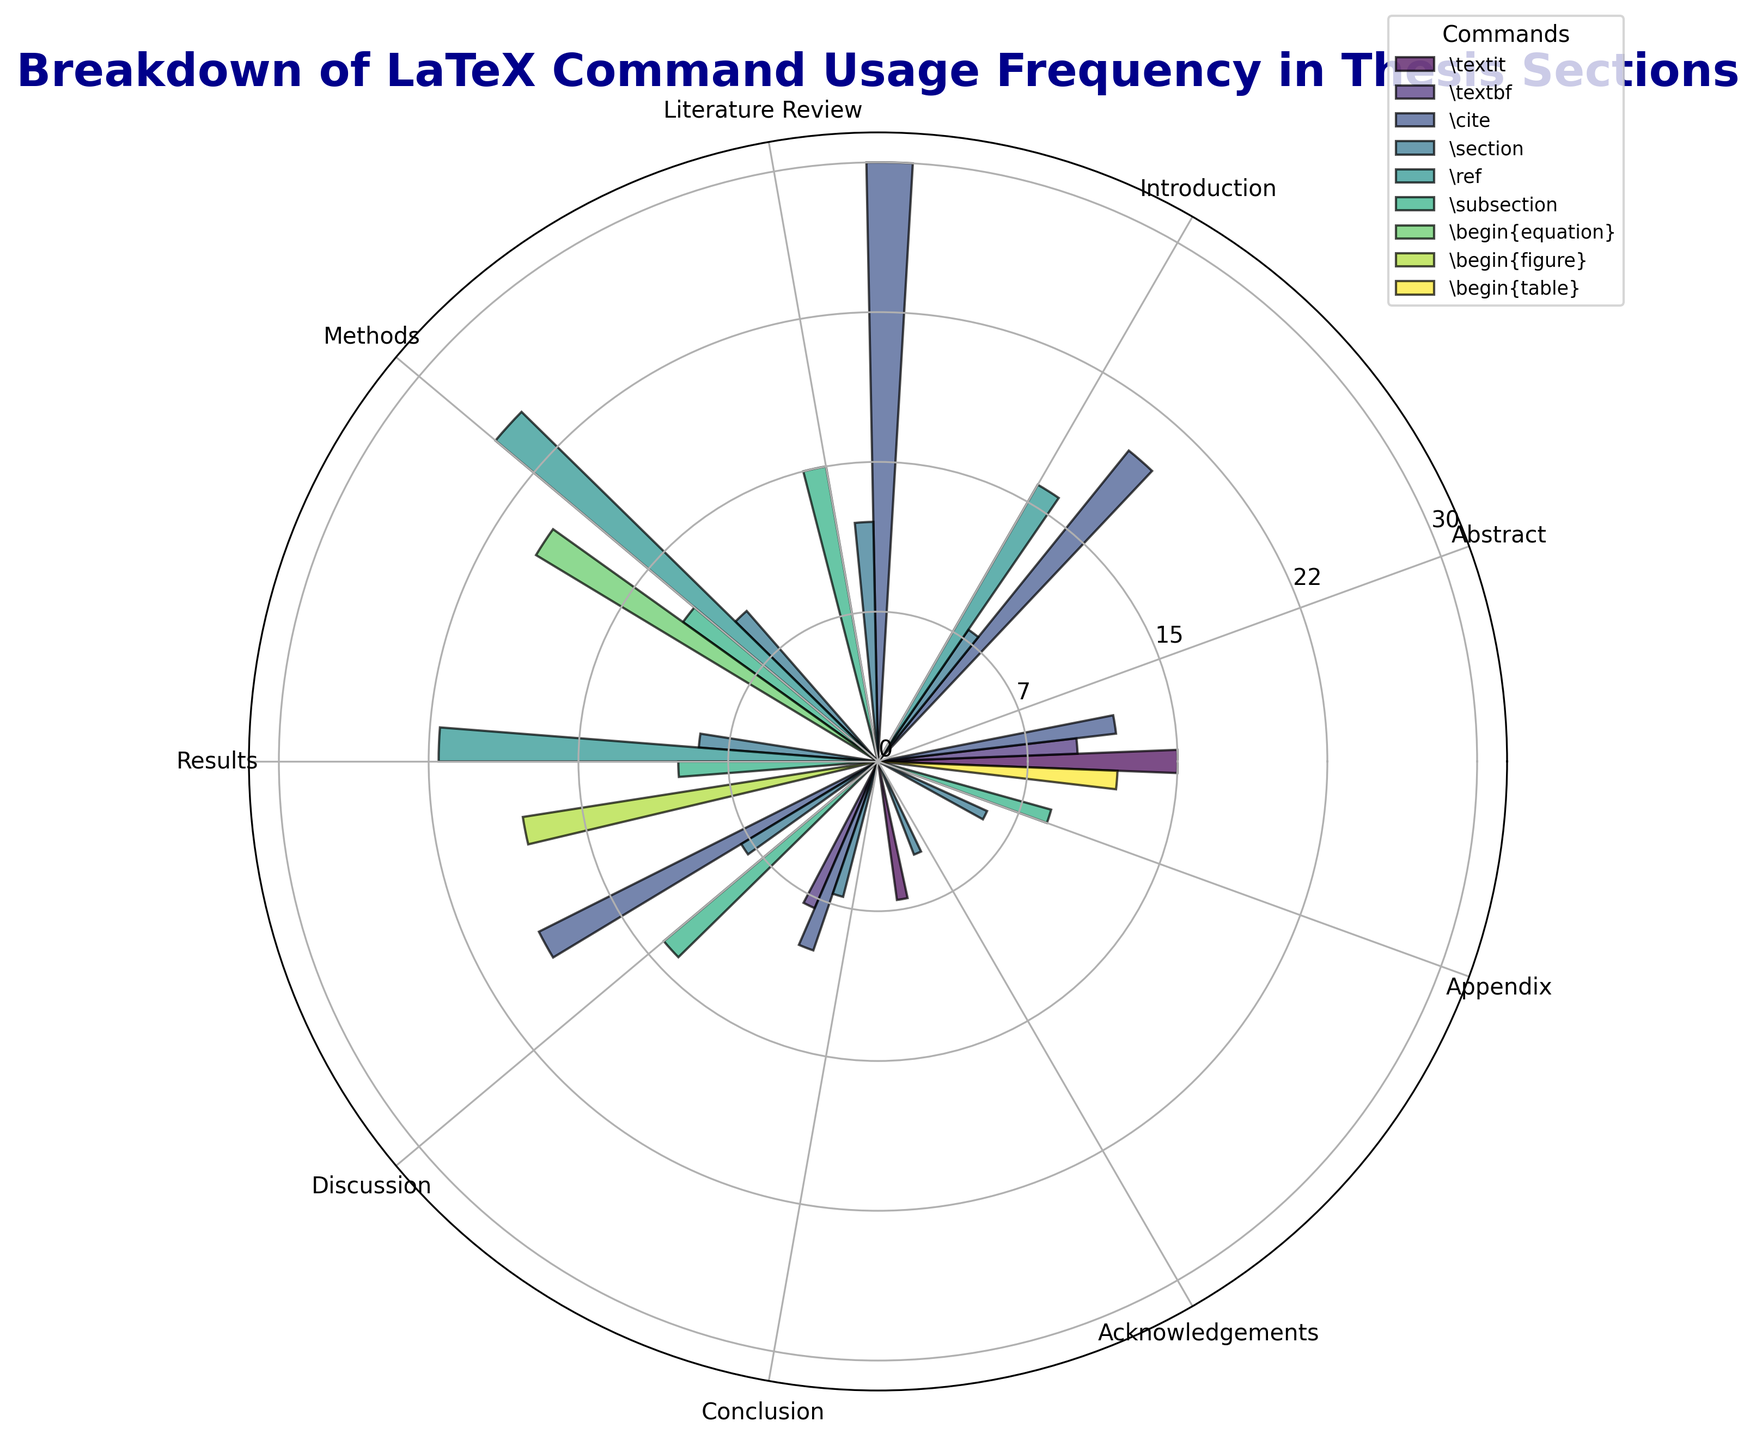Which section uses the \cite command the most? In the figure, look at the bars corresponding to the \cite command for each section and identify the one with the highest bar.
Answer: Literature Review Between the Methods and Results sections, which uses the \ref command more frequently? Compare the heights of the bars representing the \ref command in the Methods and Results sections. The taller bar indicates higher frequency.
Answer: Methods What is the total frequency of commands used in the Abstract section? Sum the frequencies of all commands in the Abstract section (\textit, \textbf, \cite).
Answer: 37 Which command is used more frequently in the Literature Review section, \subsection or \cite? Compare the heights of the bars representing the \subsection and \cite commands in the Literature Review section. The taller bar corresponds to the more frequent command.
Answer: \cite What is the average frequency of the \section command across all sections? Add the frequencies of the \section command in all sections and divide by the number of sections where it is used. (\section in Abstract: 0, Introduction: 8, Literature Review: 12, Methods: 10, Results: 9, Discussion: 8, Conclusion: 7, Acknowledgements: 5, Appendix: 6. Sum: 8 + 12 + 10 + 9 + 8 + 7 + 5 + 6 = 65. Number of sections: 8)
Answer: 8.125 Are there any sections where the \cite command is used but the \ref command is not? Identify the sections with bars for the \cite command and check if the \ref command bars are present in the same sections.
Answer: Abstract, Conclusion Which command, \textbf or \textit, is used more frequently in the Conclusion section? Compare the heights of the bars for the \textbf and \textit commands in the Conclusion section.
Answer: \textbf In which section is the \begin{figure} command used, and what is its frequency? Locate the bar for the \begin{figure} command in the polar chart and read its label and height.
Answer: Results, 18 